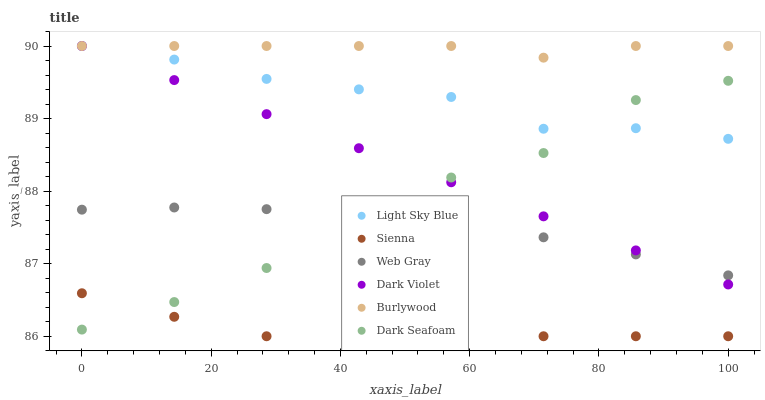Does Sienna have the minimum area under the curve?
Answer yes or no. Yes. Does Burlywood have the maximum area under the curve?
Answer yes or no. Yes. Does Dark Violet have the minimum area under the curve?
Answer yes or no. No. Does Dark Violet have the maximum area under the curve?
Answer yes or no. No. Is Dark Violet the smoothest?
Answer yes or no. Yes. Is Dark Seafoam the roughest?
Answer yes or no. Yes. Is Burlywood the smoothest?
Answer yes or no. No. Is Burlywood the roughest?
Answer yes or no. No. Does Sienna have the lowest value?
Answer yes or no. Yes. Does Dark Violet have the lowest value?
Answer yes or no. No. Does Light Sky Blue have the highest value?
Answer yes or no. Yes. Does Sienna have the highest value?
Answer yes or no. No. Is Sienna less than Web Gray?
Answer yes or no. Yes. Is Dark Violet greater than Sienna?
Answer yes or no. Yes. Does Light Sky Blue intersect Dark Seafoam?
Answer yes or no. Yes. Is Light Sky Blue less than Dark Seafoam?
Answer yes or no. No. Is Light Sky Blue greater than Dark Seafoam?
Answer yes or no. No. Does Sienna intersect Web Gray?
Answer yes or no. No. 